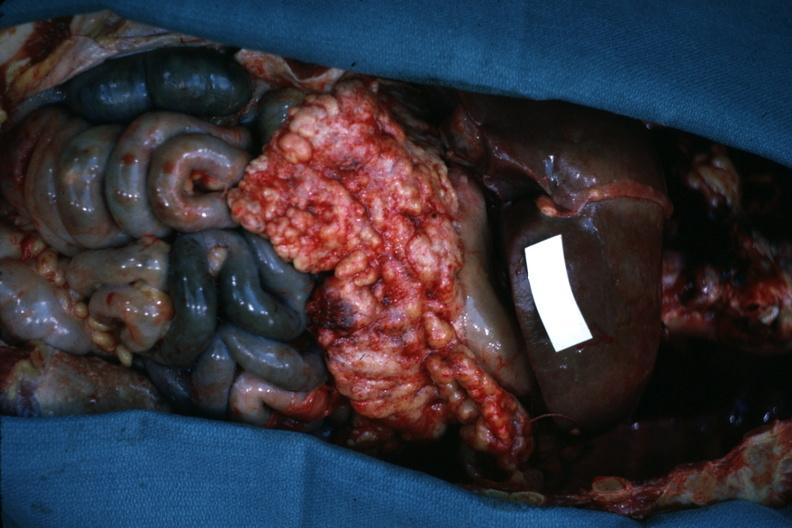what does this image show?
Answer the question using a single word or phrase. Opened abdominal cavity with massive tumor in omentum none apparent in liver nor over peritoneal surfaces gut is ischemic 